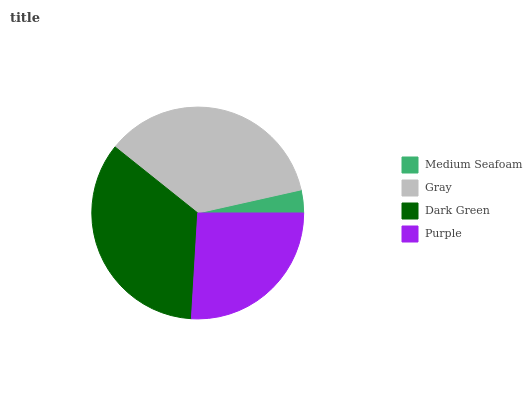Is Medium Seafoam the minimum?
Answer yes or no. Yes. Is Gray the maximum?
Answer yes or no. Yes. Is Dark Green the minimum?
Answer yes or no. No. Is Dark Green the maximum?
Answer yes or no. No. Is Gray greater than Dark Green?
Answer yes or no. Yes. Is Dark Green less than Gray?
Answer yes or no. Yes. Is Dark Green greater than Gray?
Answer yes or no. No. Is Gray less than Dark Green?
Answer yes or no. No. Is Dark Green the high median?
Answer yes or no. Yes. Is Purple the low median?
Answer yes or no. Yes. Is Gray the high median?
Answer yes or no. No. Is Medium Seafoam the low median?
Answer yes or no. No. 